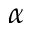Convert formula to latex. <formula><loc_0><loc_0><loc_500><loc_500>\alpha</formula> 